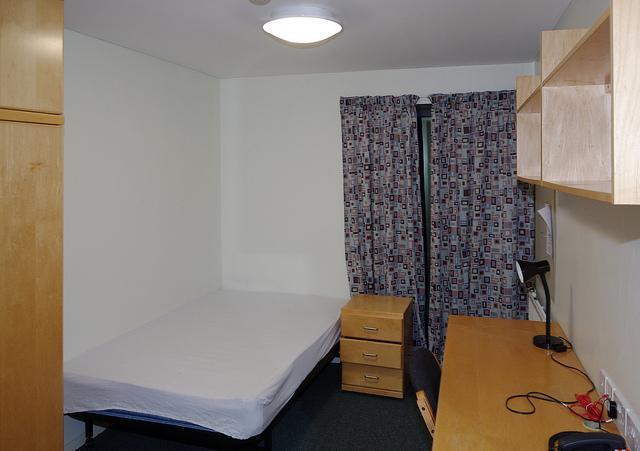How many dressers?
Give a very brief answer. 1. 